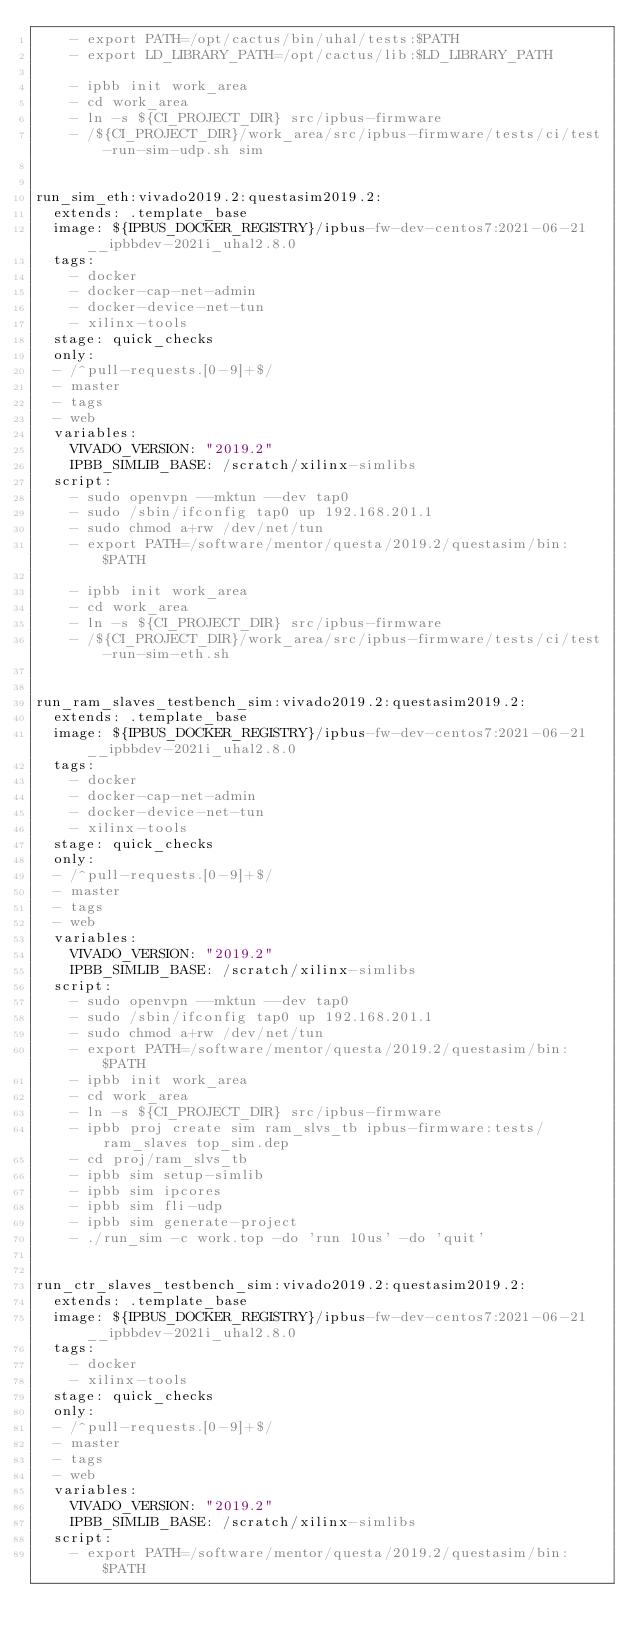Convert code to text. <code><loc_0><loc_0><loc_500><loc_500><_YAML_>    - export PATH=/opt/cactus/bin/uhal/tests:$PATH
    - export LD_LIBRARY_PATH=/opt/cactus/lib:$LD_LIBRARY_PATH

    - ipbb init work_area
    - cd work_area
    - ln -s ${CI_PROJECT_DIR} src/ipbus-firmware
    - /${CI_PROJECT_DIR}/work_area/src/ipbus-firmware/tests/ci/test-run-sim-udp.sh sim


run_sim_eth:vivado2019.2:questasim2019.2:
  extends: .template_base
  image: ${IPBUS_DOCKER_REGISTRY}/ipbus-fw-dev-centos7:2021-06-21__ipbbdev-2021i_uhal2.8.0
  tags:
    - docker
    - docker-cap-net-admin
    - docker-device-net-tun
    - xilinx-tools
  stage: quick_checks
  only:
  - /^pull-requests.[0-9]+$/
  - master
  - tags
  - web
  variables:
    VIVADO_VERSION: "2019.2"
    IPBB_SIMLIB_BASE: /scratch/xilinx-simlibs
  script:
    - sudo openvpn --mktun --dev tap0
    - sudo /sbin/ifconfig tap0 up 192.168.201.1
    - sudo chmod a+rw /dev/net/tun
    - export PATH=/software/mentor/questa/2019.2/questasim/bin:$PATH

    - ipbb init work_area
    - cd work_area
    - ln -s ${CI_PROJECT_DIR} src/ipbus-firmware
    - /${CI_PROJECT_DIR}/work_area/src/ipbus-firmware/tests/ci/test-run-sim-eth.sh


run_ram_slaves_testbench_sim:vivado2019.2:questasim2019.2:
  extends: .template_base
  image: ${IPBUS_DOCKER_REGISTRY}/ipbus-fw-dev-centos7:2021-06-21__ipbbdev-2021i_uhal2.8.0
  tags:
    - docker
    - docker-cap-net-admin
    - docker-device-net-tun
    - xilinx-tools
  stage: quick_checks
  only:
  - /^pull-requests.[0-9]+$/
  - master
  - tags
  - web
  variables:
    VIVADO_VERSION: "2019.2"
    IPBB_SIMLIB_BASE: /scratch/xilinx-simlibs
  script:
    - sudo openvpn --mktun --dev tap0
    - sudo /sbin/ifconfig tap0 up 192.168.201.1
    - sudo chmod a+rw /dev/net/tun
    - export PATH=/software/mentor/questa/2019.2/questasim/bin:$PATH
    - ipbb init work_area
    - cd work_area
    - ln -s ${CI_PROJECT_DIR} src/ipbus-firmware
    - ipbb proj create sim ram_slvs_tb ipbus-firmware:tests/ram_slaves top_sim.dep
    - cd proj/ram_slvs_tb
    - ipbb sim setup-simlib
    - ipbb sim ipcores
    - ipbb sim fli-udp
    - ipbb sim generate-project
    - ./run_sim -c work.top -do 'run 10us' -do 'quit'


run_ctr_slaves_testbench_sim:vivado2019.2:questasim2019.2:
  extends: .template_base
  image: ${IPBUS_DOCKER_REGISTRY}/ipbus-fw-dev-centos7:2021-06-21__ipbbdev-2021i_uhal2.8.0
  tags:
    - docker
    - xilinx-tools
  stage: quick_checks
  only:
  - /^pull-requests.[0-9]+$/
  - master
  - tags
  - web
  variables:
    VIVADO_VERSION: "2019.2"
    IPBB_SIMLIB_BASE: /scratch/xilinx-simlibs
  script:
    - export PATH=/software/mentor/questa/2019.2/questasim/bin:$PATH</code> 